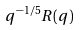<formula> <loc_0><loc_0><loc_500><loc_500>q ^ { - 1 / 5 } R ( q )</formula> 